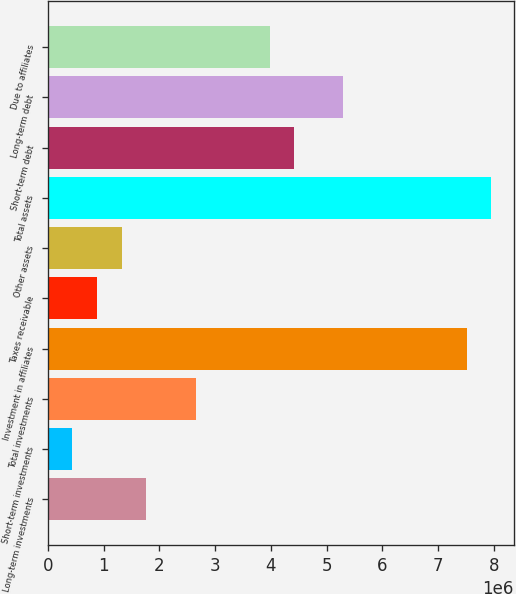Convert chart. <chart><loc_0><loc_0><loc_500><loc_500><bar_chart><fcel>Long-term investments<fcel>Short-term investments<fcel>Total investments<fcel>Investment in affiliates<fcel>Taxes receivable<fcel>Other assets<fcel>Total assets<fcel>Short-term debt<fcel>Long-term debt<fcel>Due to affiliates<nl><fcel>1.76768e+06<fcel>442182<fcel>2.65134e+06<fcel>7.51148e+06<fcel>884014<fcel>1.32585e+06<fcel>7.95332e+06<fcel>4.41866e+06<fcel>5.30233e+06<fcel>3.97683e+06<nl></chart> 